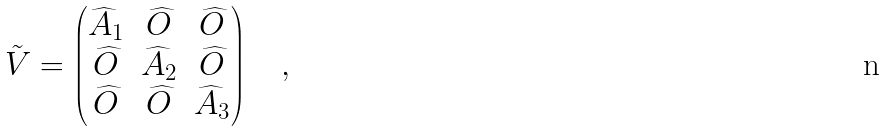<formula> <loc_0><loc_0><loc_500><loc_500>\tilde { V } = \begin{pmatrix} \widehat { A } _ { 1 } & \widehat { O } & \widehat { O } \\ \widehat { O } & \widehat { A } _ { 2 } & \widehat { O } \\ \widehat { O } & \widehat { O } & \widehat { A } _ { 3 } \end{pmatrix} \quad ,</formula> 